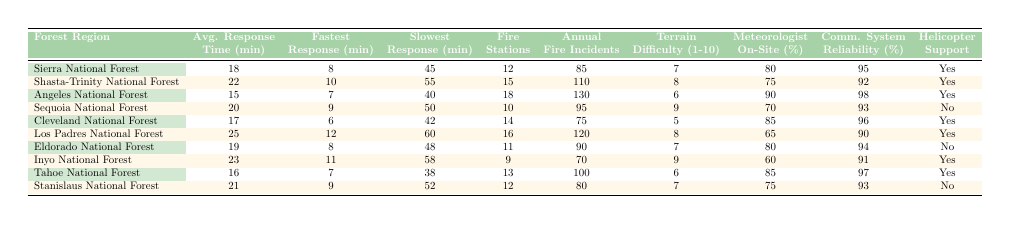What is the average response time for the Angeles National Forest? The table shows that the average response time for the Angeles National Forest is listed as 15 minutes.
Answer: 15 minutes Which forest region has the fastest response time on record? By reviewing the "Fastest Response Time" column, we see that the Angeles National Forest has the fastest recorded response time of 7 minutes.
Answer: 7 minutes What is the slowest response time recorded in the Cleveland National Forest? The "Slowest Response Time" for the Cleveland National Forest is 42 minutes as indicated in the table.
Answer: 42 minutes How many fire stations are there in the Shasta-Trinity National Forest? The table indicates that there are 15 fire stations in the Shasta-Trinity National Forest.
Answer: 15 stations Which forest region has the highest annual fire incidents? Checking the "Annual Fire Incidents" column, the Angeles National Forest has the highest number of incidents at 130.
Answer: 130 incidents What is the average difficulty rating for the Eldorado National Forest? The terrain difficulty for the Eldorado National Forest is rated at 7 on a scale of 1 to 10 according to the table.
Answer: 7 Is there helicopter support available in the Sequoia National Forest? The table shows that there is no helicopter support available in the Sequoia National Forest.
Answer: No Calculate the difference in average response time between the Los Padres National Forest and the Tahoe National Forest. The average response time for Los Padres is 25 minutes and for Tahoe is 16 minutes. The difference is 25 - 16 = 9 minutes.
Answer: 9 minutes Which forest region has both the highest terrain difficulty and the highest slowest response time? The Sequoia National Forest has a terrain difficulty of 9, which is the highest, and it has a slowest response time of 50 minutes, which is the highest slowest recorded among the regions.
Answer: Sequoia National Forest What percentage of time do meteorologists remain on-site in the Inyo National Forest? According to the table, meteorologists are on-site 60% of the time in the Inyo National Forest.
Answer: 60% 